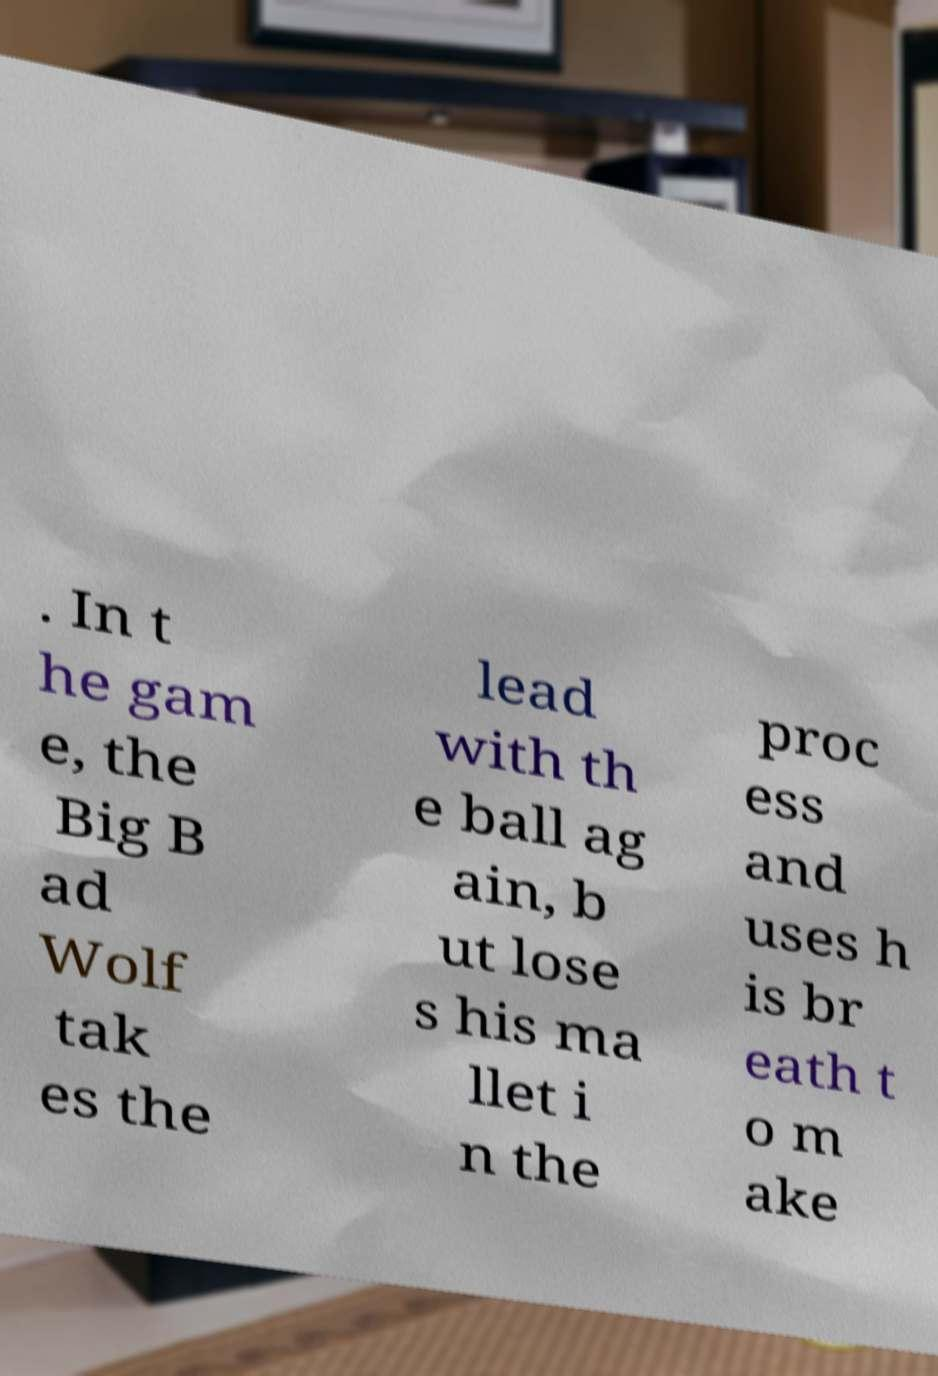There's text embedded in this image that I need extracted. Can you transcribe it verbatim? . In t he gam e, the Big B ad Wolf tak es the lead with th e ball ag ain, b ut lose s his ma llet i n the proc ess and uses h is br eath t o m ake 